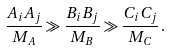<formula> <loc_0><loc_0><loc_500><loc_500>\frac { A _ { i } A _ { j } } { M _ { A } } \gg \frac { B _ { i } B _ { j } } { M _ { B } } \gg \frac { C _ { i } C _ { j } } { M _ { C } } \, .</formula> 